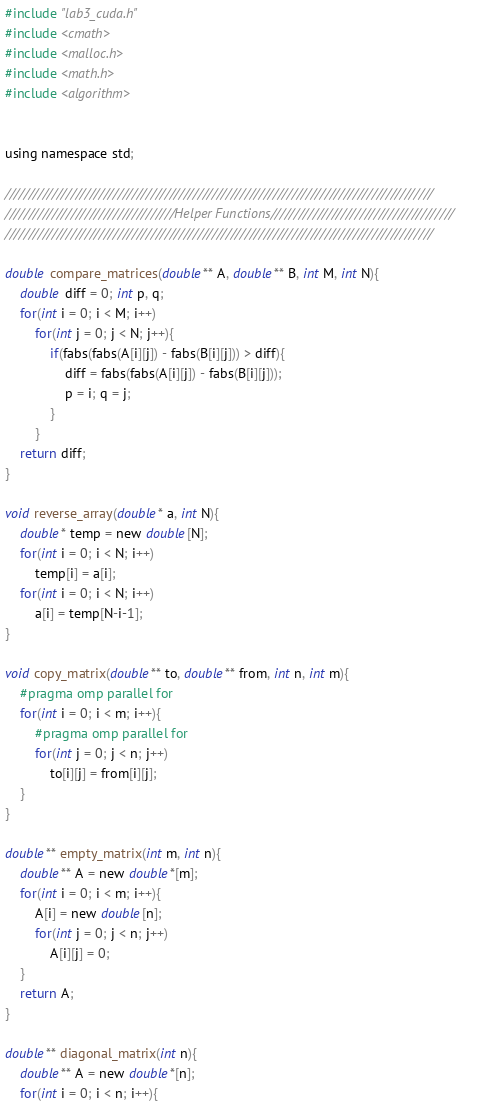<code> <loc_0><loc_0><loc_500><loc_500><_Cuda_>#include "lab3_cuda.h"
#include <cmath>
#include <malloc.h>
#include <math.h>
#include <algorithm>


using namespace std;

///////////////////////////////////////////////////////////////////////////////////////////
////////////////////////////////////Helper Functions///////////////////////////////////////
///////////////////////////////////////////////////////////////////////////////////////////

double compare_matrices(double** A, double** B, int M, int N){
    double diff = 0; int p, q;
    for(int i = 0; i < M; i++)
        for(int j = 0; j < N; j++){
            if(fabs(fabs(A[i][j]) - fabs(B[i][j])) > diff){
                diff = fabs(fabs(A[i][j]) - fabs(B[i][j]));
                p = i; q = j; 
            }
        }
    return diff;
}

void reverse_array(double* a, int N){
    double* temp = new double[N];
    for(int i = 0; i < N; i++)
        temp[i] = a[i];
    for(int i = 0; i < N; i++)
        a[i] = temp[N-i-1];
}

void copy_matrix(double** to, double** from, int n, int m){
    #pragma omp parallel for
    for(int i = 0; i < m; i++){
        #pragma omp parallel for
        for(int j = 0; j < n; j++)  
            to[i][j] = from[i][j];
    }
}

double** empty_matrix(int m, int n){
    double** A = new double*[m];
    for(int i = 0; i < m; i++){
        A[i] = new double[n];
        for(int j = 0; j < n; j++)  
            A[i][j] = 0;
    }
    return A;
}

double** diagonal_matrix(int n){
    double** A = new double*[n];
    for(int i = 0; i < n; i++){</code> 